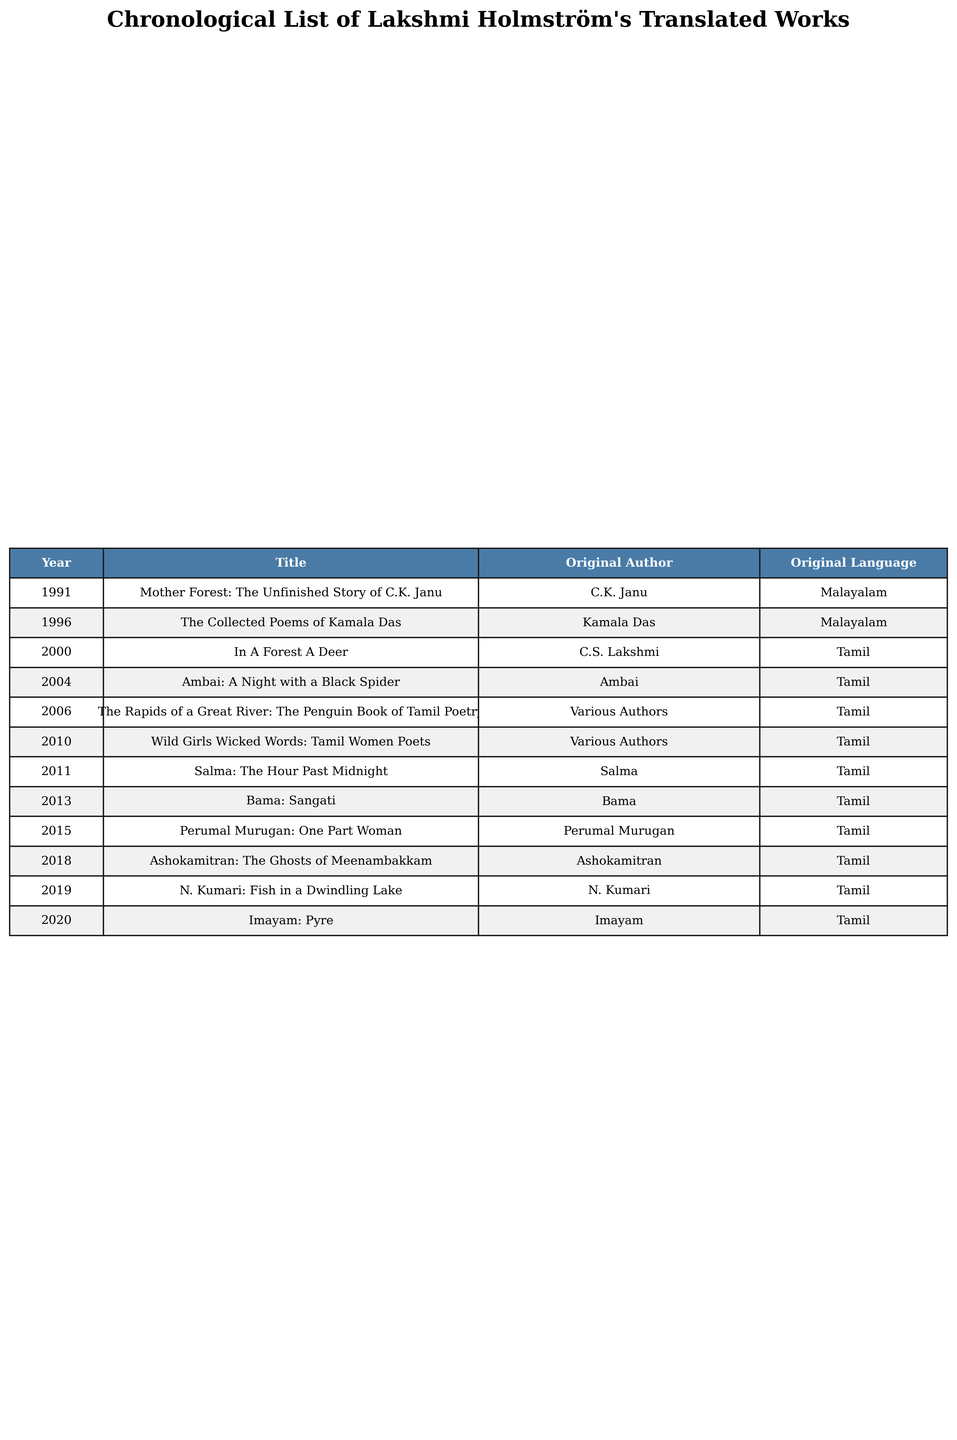What is the title of Lakshmi Holmström's first translated work? The first translated work listed is "Mother Forest: The Unfinished Story of C.K. Janu," published in 1991.
Answer: Mother Forest: The Unfinished Story of C.K. Janu How many works translated by Lakshmi Holmström were published in Tamil? By counting the titles in the table, we see that 9 out of the 10 works are in Tamil.
Answer: 9 Which original author had the most works translated by Lakshmi Holmström? By reviewing the table, we find that Perumal Murugan and Bama each have one work translated, while the others are either single works or multiple authors are represented. There is no single author with more than one in this list.
Answer: No author had more than one work What year was "The Collected Poems of Kamala Das" translated? Referring to the table, the translation occurred in 1996.
Answer: 1996 Is "The Rapids of a Great River: The Penguin Book of Tamil Poetry" edited or compiled from various authors? The table explicitly states it is a collection from various authors, indicating it is not a single-author work.
Answer: Yes How many years are there between the first and last translated works? The first work was published in 1991 and the last work in 2020. The difference in years is 2020 - 1991 = 29 years.
Answer: 29 years How many translated works were published between 2000 and 2015? By inspecting the table, the works published during this period are "In A Forest A Deer" (2000), "Ambai: A Night with a Black Spider" (2004), "The Rapids of a Great River" (2006), "Wild Girls Wicked Words" (2010), "Salma: The Hour Past Midnight" (2011), "Bama: Sangati" (2013), and "Perumal Murugan: One Part Woman" (2015), totaling 7 works.
Answer: 7 works What percentage of Lakshmi Holmström's translated works were originally in Malayalam? There are 2 works originally in Malayalam out of 10 total, so the percentage is (2/10) * 100 = 20%.
Answer: 20% Which translated work was published most recently? The table shows "Imayam: Pyre," published in 2020, as the most recent work.
Answer: Imayam: Pyre What are the original languages of the works translated by Lakshmi Holmström? From the table, the original languages are Malayalam and Tamil, with Tamil being the predominant language.
Answer: Malayalam and Tamil 